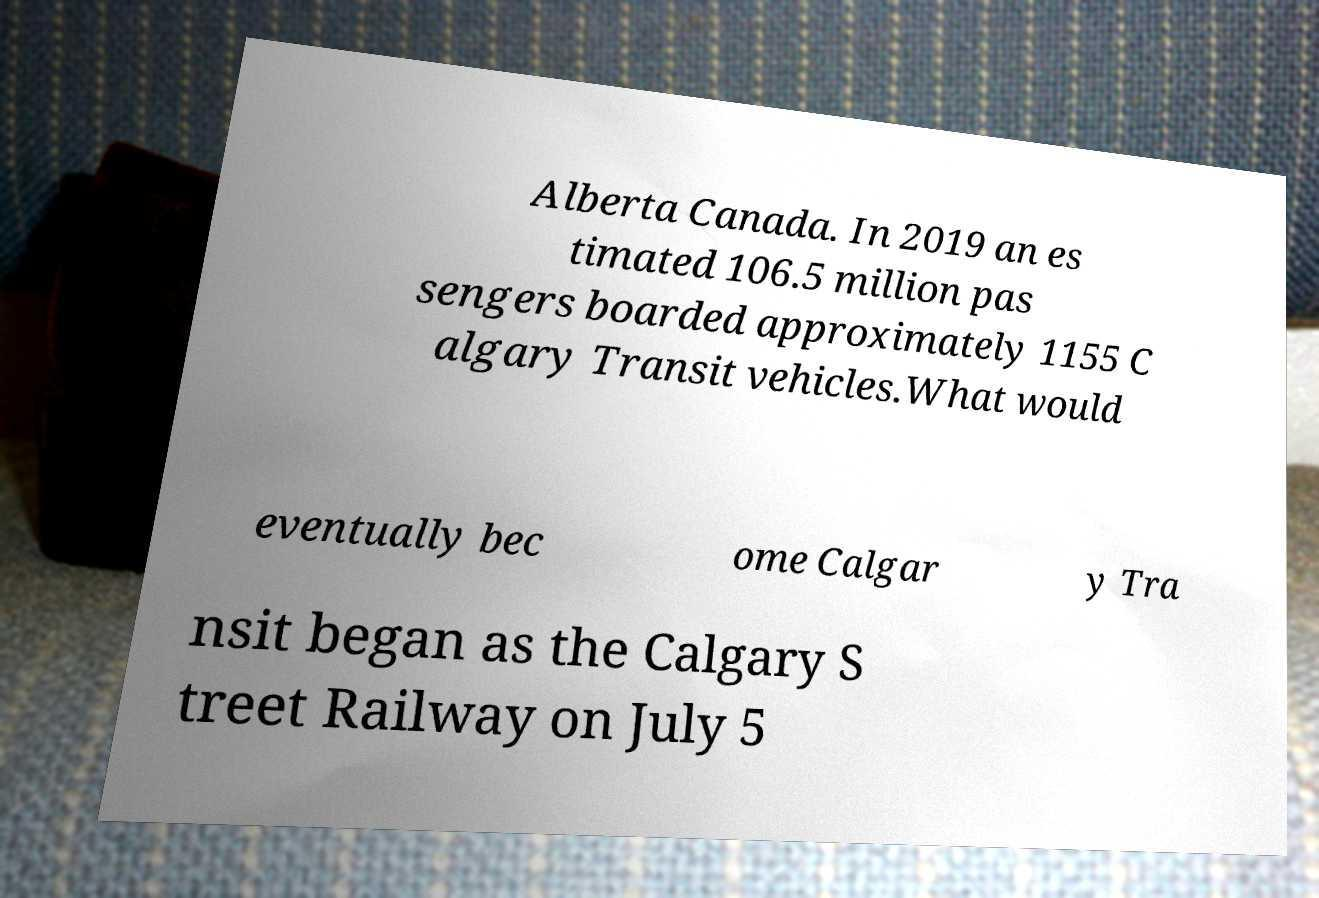For documentation purposes, I need the text within this image transcribed. Could you provide that? Alberta Canada. In 2019 an es timated 106.5 million pas sengers boarded approximately 1155 C algary Transit vehicles.What would eventually bec ome Calgar y Tra nsit began as the Calgary S treet Railway on July 5 